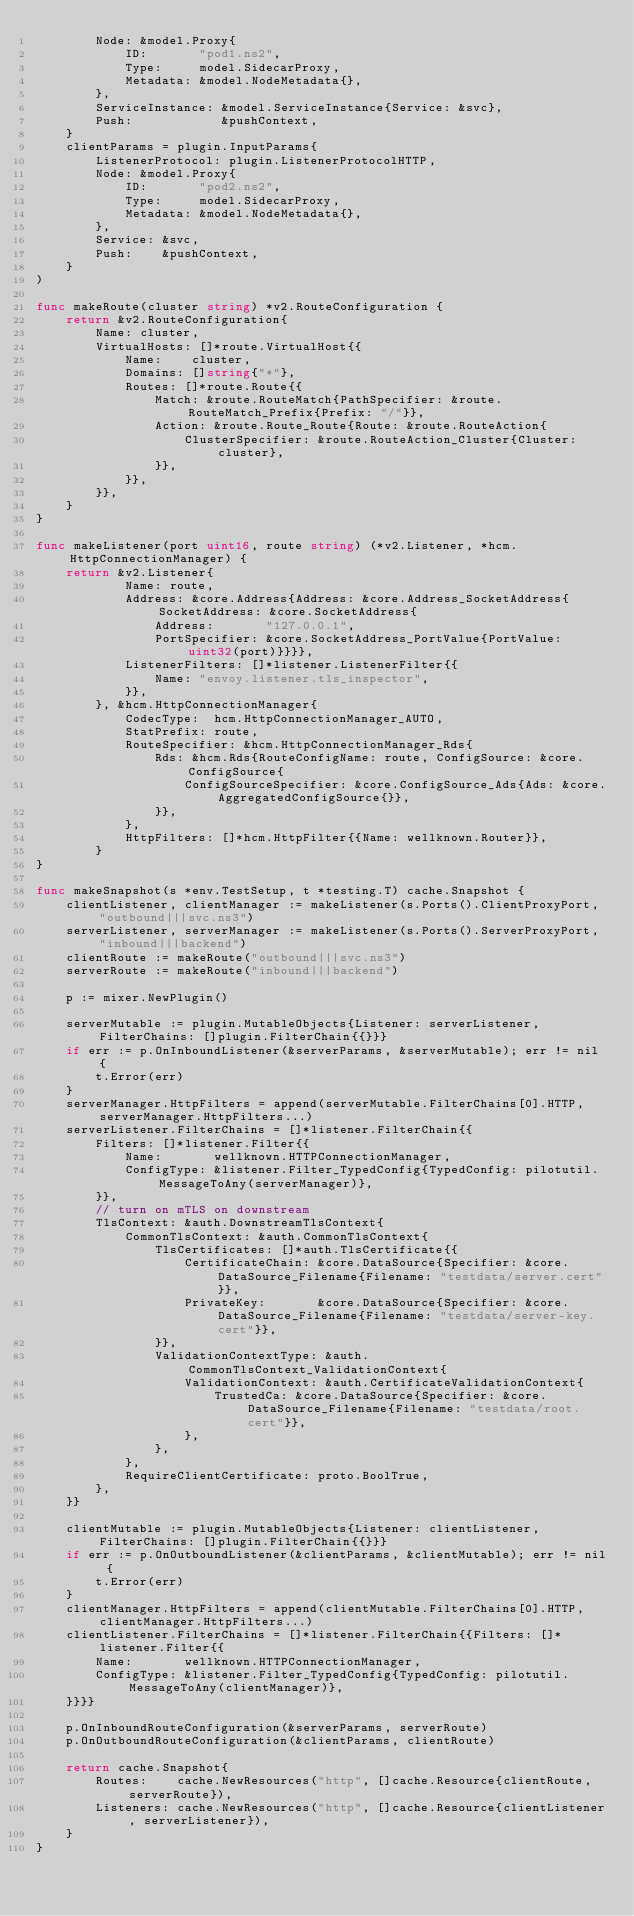<code> <loc_0><loc_0><loc_500><loc_500><_Go_>		Node: &model.Proxy{
			ID:       "pod1.ns2",
			Type:     model.SidecarProxy,
			Metadata: &model.NodeMetadata{},
		},
		ServiceInstance: &model.ServiceInstance{Service: &svc},
		Push:            &pushContext,
	}
	clientParams = plugin.InputParams{
		ListenerProtocol: plugin.ListenerProtocolHTTP,
		Node: &model.Proxy{
			ID:       "pod2.ns2",
			Type:     model.SidecarProxy,
			Metadata: &model.NodeMetadata{},
		},
		Service: &svc,
		Push:    &pushContext,
	}
)

func makeRoute(cluster string) *v2.RouteConfiguration {
	return &v2.RouteConfiguration{
		Name: cluster,
		VirtualHosts: []*route.VirtualHost{{
			Name:    cluster,
			Domains: []string{"*"},
			Routes: []*route.Route{{
				Match: &route.RouteMatch{PathSpecifier: &route.RouteMatch_Prefix{Prefix: "/"}},
				Action: &route.Route_Route{Route: &route.RouteAction{
					ClusterSpecifier: &route.RouteAction_Cluster{Cluster: cluster},
				}},
			}},
		}},
	}
}

func makeListener(port uint16, route string) (*v2.Listener, *hcm.HttpConnectionManager) {
	return &v2.Listener{
			Name: route,
			Address: &core.Address{Address: &core.Address_SocketAddress{SocketAddress: &core.SocketAddress{
				Address:       "127.0.0.1",
				PortSpecifier: &core.SocketAddress_PortValue{PortValue: uint32(port)}}}},
			ListenerFilters: []*listener.ListenerFilter{{
				Name: "envoy.listener.tls_inspector",
			}},
		}, &hcm.HttpConnectionManager{
			CodecType:  hcm.HttpConnectionManager_AUTO,
			StatPrefix: route,
			RouteSpecifier: &hcm.HttpConnectionManager_Rds{
				Rds: &hcm.Rds{RouteConfigName: route, ConfigSource: &core.ConfigSource{
					ConfigSourceSpecifier: &core.ConfigSource_Ads{Ads: &core.AggregatedConfigSource{}},
				}},
			},
			HttpFilters: []*hcm.HttpFilter{{Name: wellknown.Router}},
		}
}

func makeSnapshot(s *env.TestSetup, t *testing.T) cache.Snapshot {
	clientListener, clientManager := makeListener(s.Ports().ClientProxyPort, "outbound|||svc.ns3")
	serverListener, serverManager := makeListener(s.Ports().ServerProxyPort, "inbound|||backend")
	clientRoute := makeRoute("outbound|||svc.ns3")
	serverRoute := makeRoute("inbound|||backend")

	p := mixer.NewPlugin()

	serverMutable := plugin.MutableObjects{Listener: serverListener, FilterChains: []plugin.FilterChain{{}}}
	if err := p.OnInboundListener(&serverParams, &serverMutable); err != nil {
		t.Error(err)
	}
	serverManager.HttpFilters = append(serverMutable.FilterChains[0].HTTP, serverManager.HttpFilters...)
	serverListener.FilterChains = []*listener.FilterChain{{
		Filters: []*listener.Filter{{
			Name:       wellknown.HTTPConnectionManager,
			ConfigType: &listener.Filter_TypedConfig{TypedConfig: pilotutil.MessageToAny(serverManager)},
		}},
		// turn on mTLS on downstream
		TlsContext: &auth.DownstreamTlsContext{
			CommonTlsContext: &auth.CommonTlsContext{
				TlsCertificates: []*auth.TlsCertificate{{
					CertificateChain: &core.DataSource{Specifier: &core.DataSource_Filename{Filename: "testdata/server.cert"}},
					PrivateKey:       &core.DataSource{Specifier: &core.DataSource_Filename{Filename: "testdata/server-key.cert"}},
				}},
				ValidationContextType: &auth.CommonTlsContext_ValidationContext{
					ValidationContext: &auth.CertificateValidationContext{
						TrustedCa: &core.DataSource{Specifier: &core.DataSource_Filename{Filename: "testdata/root.cert"}},
					},
				},
			},
			RequireClientCertificate: proto.BoolTrue,
		},
	}}

	clientMutable := plugin.MutableObjects{Listener: clientListener, FilterChains: []plugin.FilterChain{{}}}
	if err := p.OnOutboundListener(&clientParams, &clientMutable); err != nil {
		t.Error(err)
	}
	clientManager.HttpFilters = append(clientMutable.FilterChains[0].HTTP, clientManager.HttpFilters...)
	clientListener.FilterChains = []*listener.FilterChain{{Filters: []*listener.Filter{{
		Name:       wellknown.HTTPConnectionManager,
		ConfigType: &listener.Filter_TypedConfig{TypedConfig: pilotutil.MessageToAny(clientManager)},
	}}}}

	p.OnInboundRouteConfiguration(&serverParams, serverRoute)
	p.OnOutboundRouteConfiguration(&clientParams, clientRoute)

	return cache.Snapshot{
		Routes:    cache.NewResources("http", []cache.Resource{clientRoute, serverRoute}),
		Listeners: cache.NewResources("http", []cache.Resource{clientListener, serverListener}),
	}
}
</code> 